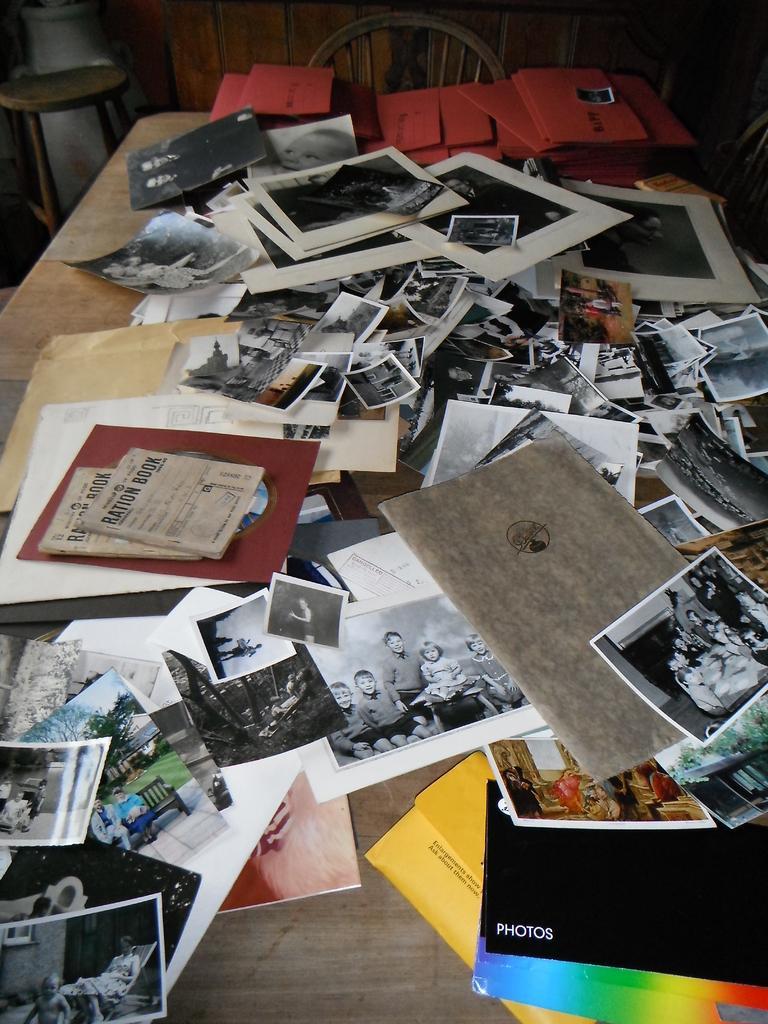Please provide a concise description of this image. In this picture we can see a wooden table and on the table there are photos, books, papers and files. Behind the table there is a stool, a wheel and some objects. 